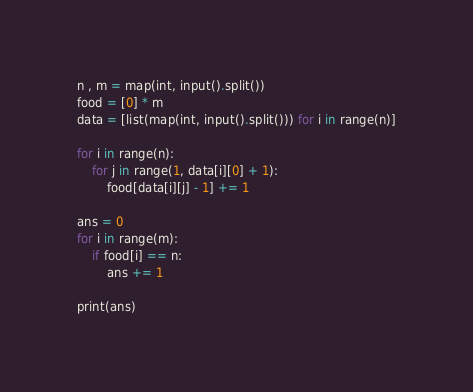Convert code to text. <code><loc_0><loc_0><loc_500><loc_500><_Python_>n , m = map(int, input().split())
food = [0] * m
data = [list(map(int, input().split())) for i in range(n)]

for i in range(n):
    for j in range(1, data[i][0] + 1):
        food[data[i][j] - 1] += 1

ans = 0
for i in range(m):
    if food[i] == n:
        ans += 1

print(ans)</code> 